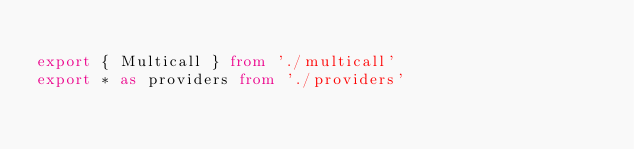Convert code to text. <code><loc_0><loc_0><loc_500><loc_500><_TypeScript_>
export { Multicall } from './multicall'
export * as providers from './providers'
</code> 